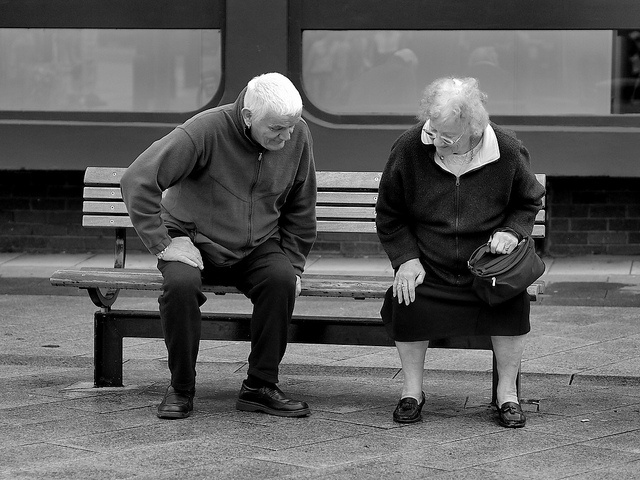Describe the objects in this image and their specific colors. I can see people in black, gray, darkgray, and lightgray tones, people in black, darkgray, gray, and lightgray tones, bench in black, darkgray, gray, and lightgray tones, and handbag in black, gray, lightgray, and darkgray tones in this image. 